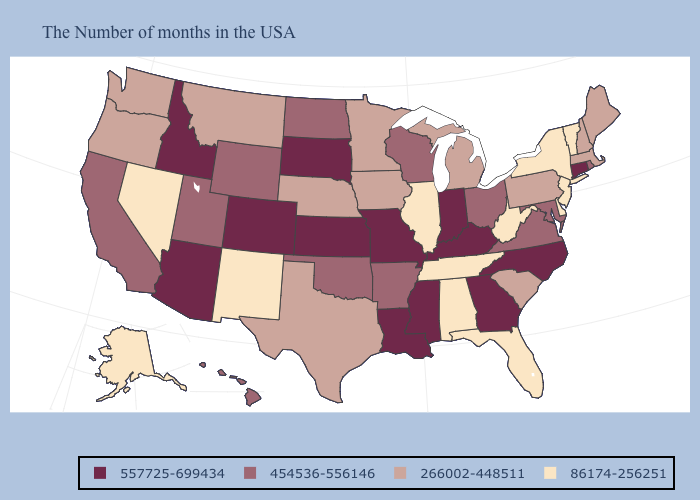Is the legend a continuous bar?
Concise answer only. No. What is the lowest value in states that border Rhode Island?
Answer briefly. 266002-448511. Among the states that border North Dakota , which have the lowest value?
Answer briefly. Minnesota, Montana. Name the states that have a value in the range 557725-699434?
Answer briefly. Connecticut, North Carolina, Georgia, Kentucky, Indiana, Mississippi, Louisiana, Missouri, Kansas, South Dakota, Colorado, Arizona, Idaho. Which states have the lowest value in the Northeast?
Answer briefly. Vermont, New York, New Jersey. Does Tennessee have the same value as New Hampshire?
Give a very brief answer. No. Among the states that border Arkansas , which have the lowest value?
Be succinct. Tennessee. Which states have the lowest value in the USA?
Keep it brief. Vermont, New York, New Jersey, Delaware, West Virginia, Florida, Alabama, Tennessee, Illinois, New Mexico, Nevada, Alaska. Does the first symbol in the legend represent the smallest category?
Answer briefly. No. What is the highest value in the Northeast ?
Keep it brief. 557725-699434. Does Wyoming have the same value as Georgia?
Concise answer only. No. What is the value of Iowa?
Keep it brief. 266002-448511. Which states have the highest value in the USA?
Write a very short answer. Connecticut, North Carolina, Georgia, Kentucky, Indiana, Mississippi, Louisiana, Missouri, Kansas, South Dakota, Colorado, Arizona, Idaho. What is the lowest value in the USA?
Short answer required. 86174-256251. Which states have the lowest value in the USA?
Give a very brief answer. Vermont, New York, New Jersey, Delaware, West Virginia, Florida, Alabama, Tennessee, Illinois, New Mexico, Nevada, Alaska. 